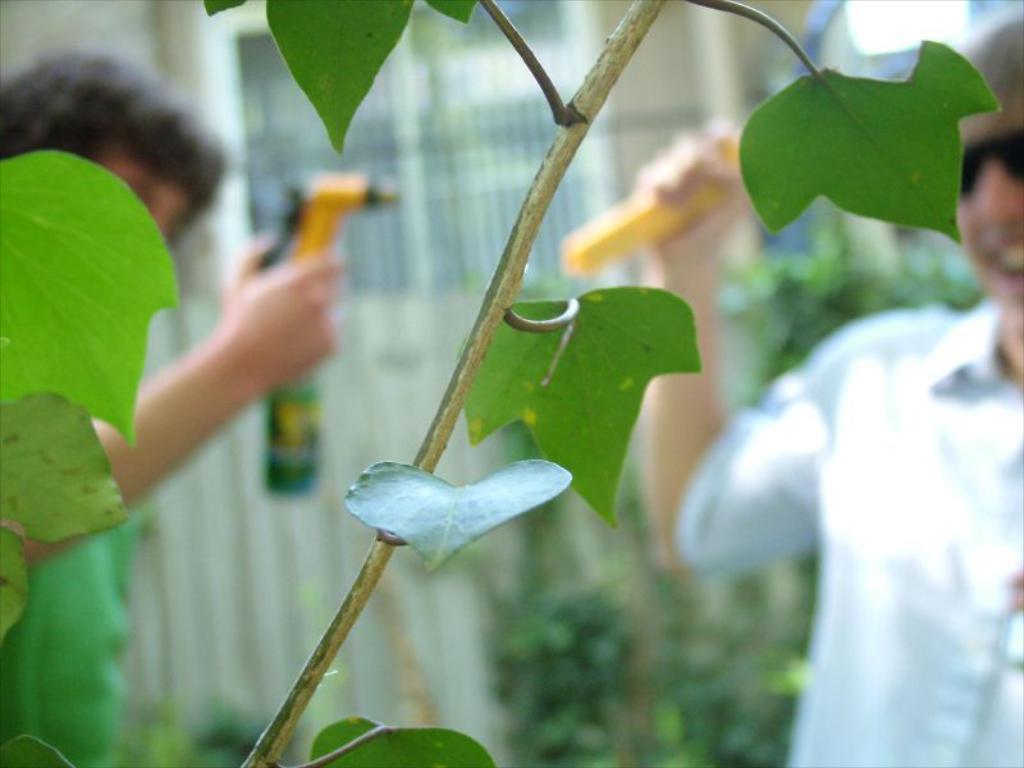Can you describe this image briefly? In the foreground of this image, there are leaves to a stem. Behind it, there are two people standing and holding objects and the background image is blur. 